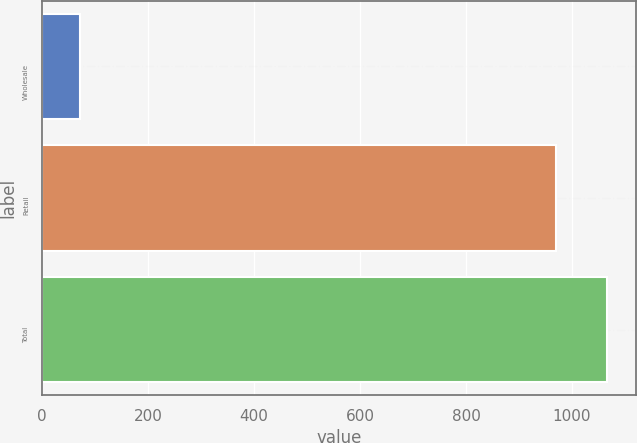Convert chart. <chart><loc_0><loc_0><loc_500><loc_500><bar_chart><fcel>Wholesale<fcel>Retail<fcel>Total<nl><fcel>71.1<fcel>969.9<fcel>1066.89<nl></chart> 